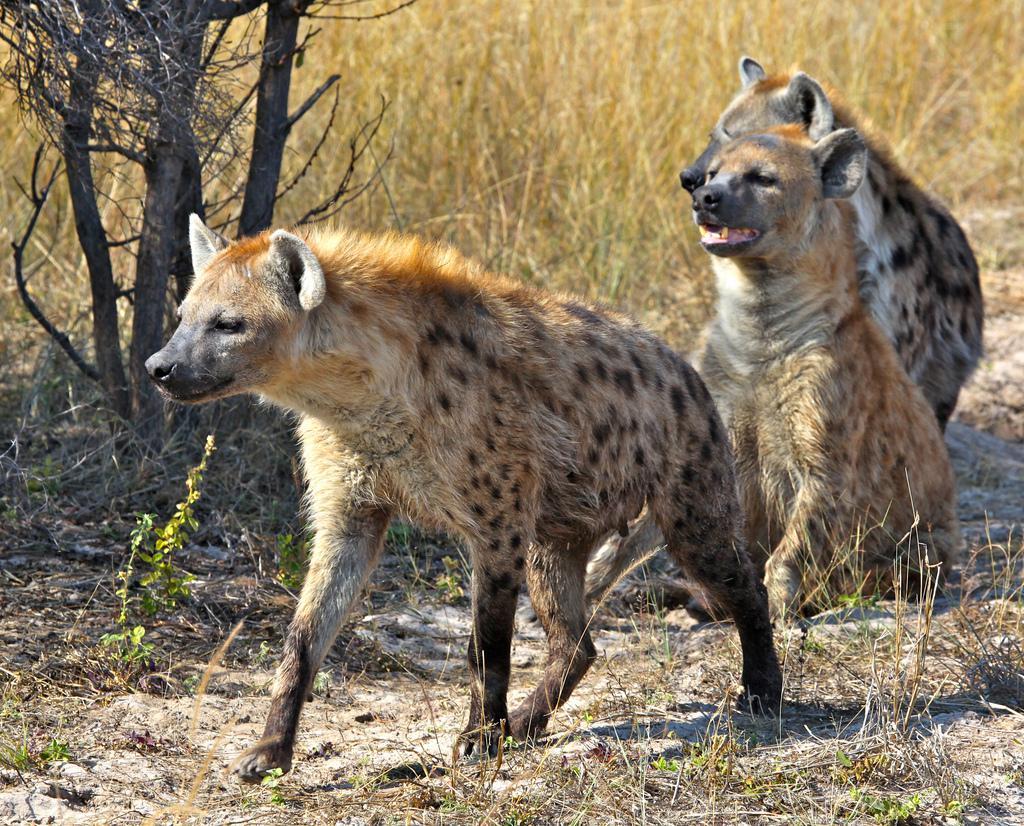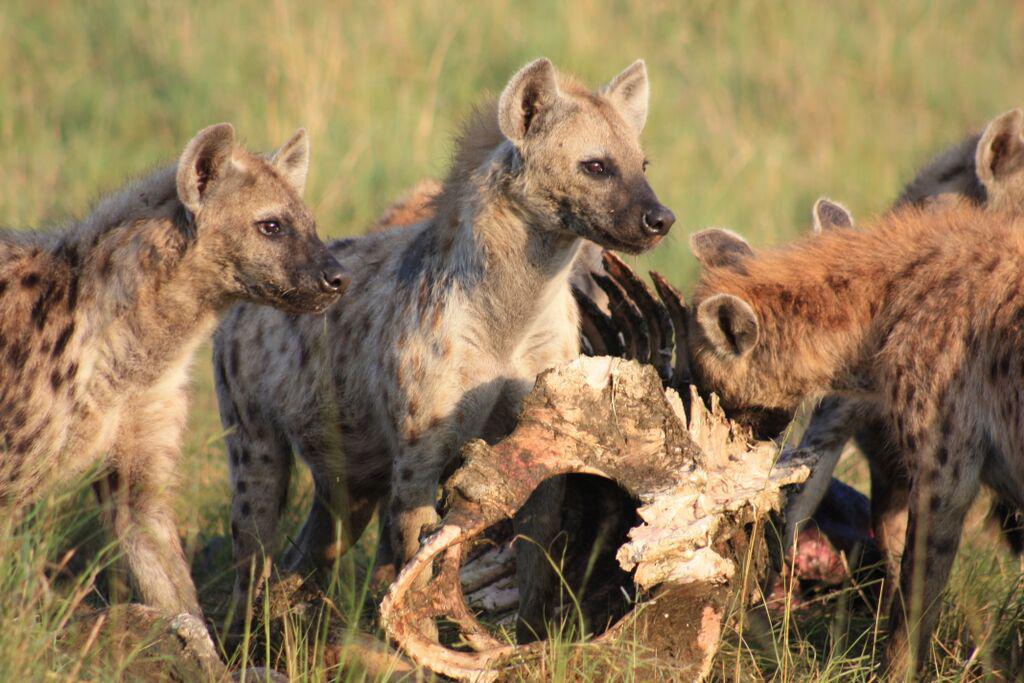The first image is the image on the left, the second image is the image on the right. For the images displayed, is the sentence "Hyenas are attacking a lion." factually correct? Answer yes or no. No. The first image is the image on the left, the second image is the image on the right. Given the left and right images, does the statement "Multiple hyenas and one open-mouthed lion are engaged in action in one image." hold true? Answer yes or no. No. 